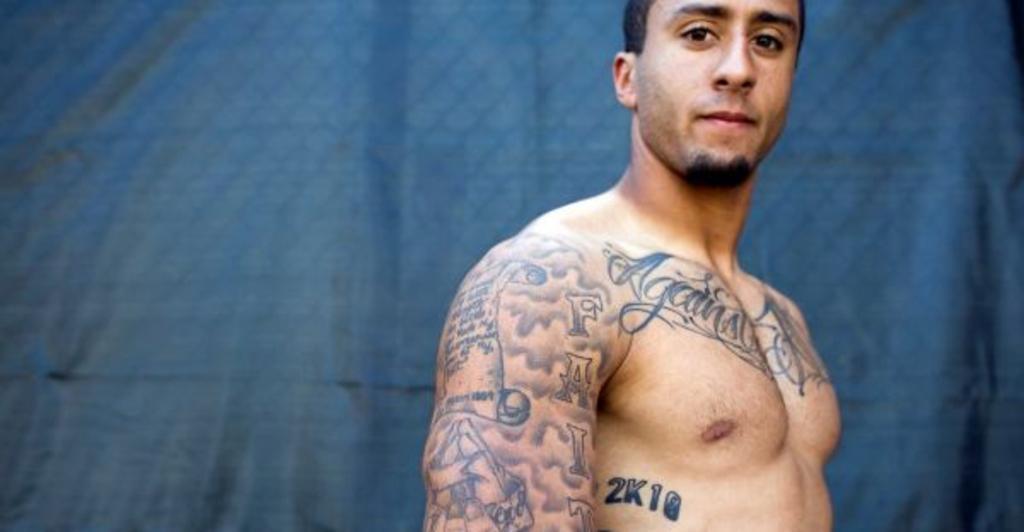In one or two sentences, can you explain what this image depicts? In the image we can see there is a man standing and there is tattooed on his body. Behind there is blue colour cover. 